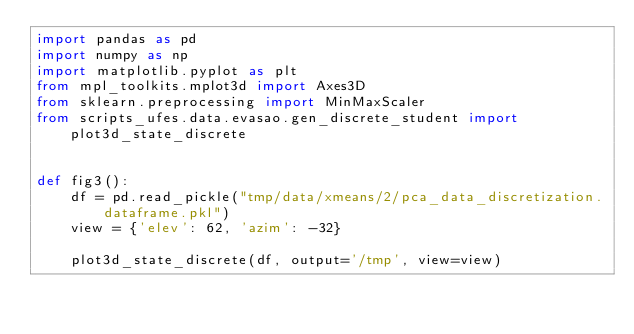<code> <loc_0><loc_0><loc_500><loc_500><_Python_>import pandas as pd
import numpy as np
import matplotlib.pyplot as plt
from mpl_toolkits.mplot3d import Axes3D
from sklearn.preprocessing import MinMaxScaler
from scripts_ufes.data.evasao.gen_discrete_student import plot3d_state_discrete


def fig3():
    df = pd.read_pickle("tmp/data/xmeans/2/pca_data_discretization.dataframe.pkl")
    view = {'elev': 62, 'azim': -32}

    plot3d_state_discrete(df, output='/tmp', view=view)
</code> 